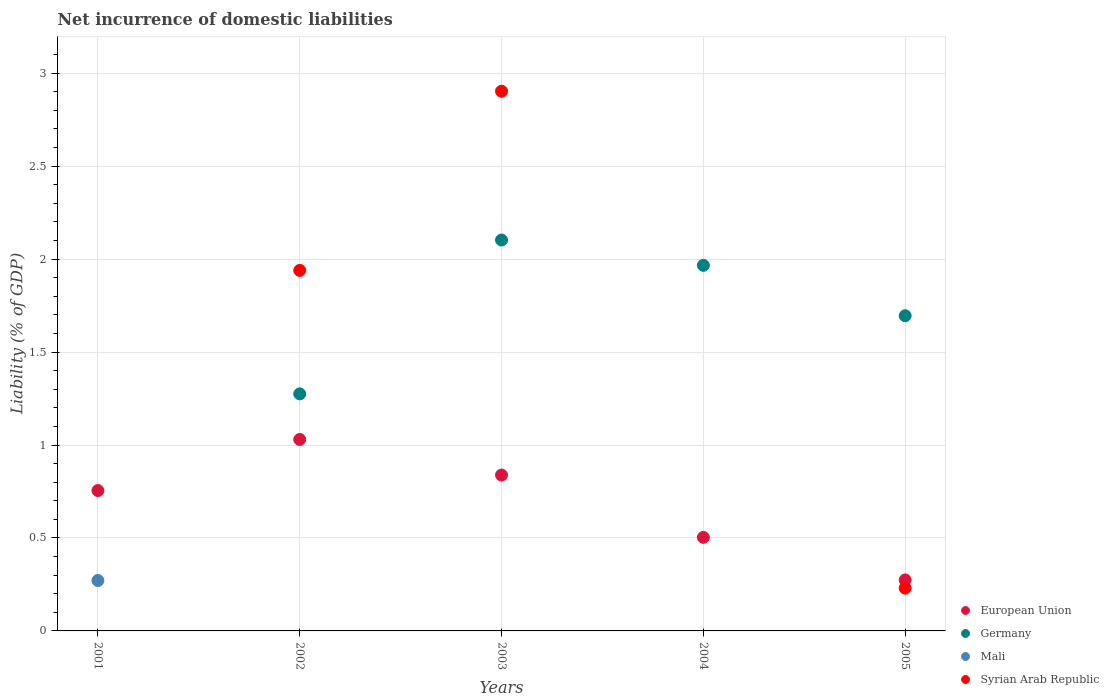How many different coloured dotlines are there?
Your response must be concise. 4. What is the net incurrence of domestic liabilities in European Union in 2003?
Offer a terse response. 0.84. Across all years, what is the maximum net incurrence of domestic liabilities in Mali?
Ensure brevity in your answer.  0.27. Across all years, what is the minimum net incurrence of domestic liabilities in Mali?
Your answer should be very brief. 0. In which year was the net incurrence of domestic liabilities in Syrian Arab Republic maximum?
Provide a succinct answer. 2003. What is the total net incurrence of domestic liabilities in European Union in the graph?
Offer a terse response. 3.4. What is the difference between the net incurrence of domestic liabilities in Syrian Arab Republic in 2002 and that in 2005?
Keep it short and to the point. 1.71. What is the difference between the net incurrence of domestic liabilities in European Union in 2004 and the net incurrence of domestic liabilities in Syrian Arab Republic in 2003?
Provide a short and direct response. -2.4. What is the average net incurrence of domestic liabilities in Mali per year?
Offer a terse response. 0.05. In the year 2004, what is the difference between the net incurrence of domestic liabilities in Germany and net incurrence of domestic liabilities in European Union?
Your answer should be compact. 1.46. What is the ratio of the net incurrence of domestic liabilities in European Union in 2002 to that in 2005?
Offer a terse response. 3.75. Is the net incurrence of domestic liabilities in Syrian Arab Republic in 2002 less than that in 2003?
Keep it short and to the point. Yes. Is the difference between the net incurrence of domestic liabilities in Germany in 2003 and 2005 greater than the difference between the net incurrence of domestic liabilities in European Union in 2003 and 2005?
Keep it short and to the point. No. What is the difference between the highest and the second highest net incurrence of domestic liabilities in European Union?
Your response must be concise. 0.19. What is the difference between the highest and the lowest net incurrence of domestic liabilities in Germany?
Keep it short and to the point. 2.1. In how many years, is the net incurrence of domestic liabilities in Mali greater than the average net incurrence of domestic liabilities in Mali taken over all years?
Your response must be concise. 1. Is it the case that in every year, the sum of the net incurrence of domestic liabilities in Germany and net incurrence of domestic liabilities in European Union  is greater than the sum of net incurrence of domestic liabilities in Mali and net incurrence of domestic liabilities in Syrian Arab Republic?
Your answer should be very brief. No. Is it the case that in every year, the sum of the net incurrence of domestic liabilities in Syrian Arab Republic and net incurrence of domestic liabilities in European Union  is greater than the net incurrence of domestic liabilities in Germany?
Give a very brief answer. No. Does the net incurrence of domestic liabilities in Mali monotonically increase over the years?
Your answer should be very brief. No. Is the net incurrence of domestic liabilities in Syrian Arab Republic strictly greater than the net incurrence of domestic liabilities in Mali over the years?
Offer a terse response. No. What is the difference between two consecutive major ticks on the Y-axis?
Provide a succinct answer. 0.5. Does the graph contain grids?
Offer a terse response. Yes. How are the legend labels stacked?
Make the answer very short. Vertical. What is the title of the graph?
Offer a very short reply. Net incurrence of domestic liabilities. Does "Belgium" appear as one of the legend labels in the graph?
Make the answer very short. No. What is the label or title of the X-axis?
Your answer should be very brief. Years. What is the label or title of the Y-axis?
Ensure brevity in your answer.  Liability (% of GDP). What is the Liability (% of GDP) of European Union in 2001?
Make the answer very short. 0.75. What is the Liability (% of GDP) of Germany in 2001?
Offer a terse response. 0. What is the Liability (% of GDP) in Mali in 2001?
Make the answer very short. 0.27. What is the Liability (% of GDP) of Syrian Arab Republic in 2001?
Offer a terse response. 0. What is the Liability (% of GDP) of European Union in 2002?
Offer a very short reply. 1.03. What is the Liability (% of GDP) in Germany in 2002?
Provide a succinct answer. 1.28. What is the Liability (% of GDP) of Mali in 2002?
Offer a terse response. 0. What is the Liability (% of GDP) of Syrian Arab Republic in 2002?
Your answer should be very brief. 1.94. What is the Liability (% of GDP) of European Union in 2003?
Make the answer very short. 0.84. What is the Liability (% of GDP) of Germany in 2003?
Keep it short and to the point. 2.1. What is the Liability (% of GDP) of Syrian Arab Republic in 2003?
Ensure brevity in your answer.  2.9. What is the Liability (% of GDP) in European Union in 2004?
Provide a succinct answer. 0.5. What is the Liability (% of GDP) in Germany in 2004?
Your response must be concise. 1.97. What is the Liability (% of GDP) of Mali in 2004?
Your answer should be very brief. 0. What is the Liability (% of GDP) in Syrian Arab Republic in 2004?
Make the answer very short. 0. What is the Liability (% of GDP) of European Union in 2005?
Your response must be concise. 0.27. What is the Liability (% of GDP) of Germany in 2005?
Your response must be concise. 1.7. What is the Liability (% of GDP) of Syrian Arab Republic in 2005?
Offer a very short reply. 0.23. Across all years, what is the maximum Liability (% of GDP) of European Union?
Make the answer very short. 1.03. Across all years, what is the maximum Liability (% of GDP) in Germany?
Give a very brief answer. 2.1. Across all years, what is the maximum Liability (% of GDP) of Mali?
Provide a succinct answer. 0.27. Across all years, what is the maximum Liability (% of GDP) in Syrian Arab Republic?
Give a very brief answer. 2.9. Across all years, what is the minimum Liability (% of GDP) in European Union?
Offer a very short reply. 0.27. Across all years, what is the minimum Liability (% of GDP) in Mali?
Ensure brevity in your answer.  0. Across all years, what is the minimum Liability (% of GDP) in Syrian Arab Republic?
Ensure brevity in your answer.  0. What is the total Liability (% of GDP) of European Union in the graph?
Provide a succinct answer. 3.4. What is the total Liability (% of GDP) in Germany in the graph?
Your response must be concise. 7.04. What is the total Liability (% of GDP) in Mali in the graph?
Ensure brevity in your answer.  0.27. What is the total Liability (% of GDP) in Syrian Arab Republic in the graph?
Provide a short and direct response. 5.07. What is the difference between the Liability (% of GDP) of European Union in 2001 and that in 2002?
Your answer should be very brief. -0.27. What is the difference between the Liability (% of GDP) in European Union in 2001 and that in 2003?
Your answer should be very brief. -0.08. What is the difference between the Liability (% of GDP) of European Union in 2001 and that in 2004?
Your answer should be very brief. 0.25. What is the difference between the Liability (% of GDP) of European Union in 2001 and that in 2005?
Give a very brief answer. 0.48. What is the difference between the Liability (% of GDP) of European Union in 2002 and that in 2003?
Provide a succinct answer. 0.19. What is the difference between the Liability (% of GDP) in Germany in 2002 and that in 2003?
Offer a very short reply. -0.83. What is the difference between the Liability (% of GDP) of Syrian Arab Republic in 2002 and that in 2003?
Make the answer very short. -0.96. What is the difference between the Liability (% of GDP) in European Union in 2002 and that in 2004?
Your answer should be compact. 0.53. What is the difference between the Liability (% of GDP) of Germany in 2002 and that in 2004?
Give a very brief answer. -0.69. What is the difference between the Liability (% of GDP) of European Union in 2002 and that in 2005?
Ensure brevity in your answer.  0.76. What is the difference between the Liability (% of GDP) in Germany in 2002 and that in 2005?
Give a very brief answer. -0.42. What is the difference between the Liability (% of GDP) of Syrian Arab Republic in 2002 and that in 2005?
Give a very brief answer. 1.71. What is the difference between the Liability (% of GDP) of European Union in 2003 and that in 2004?
Keep it short and to the point. 0.34. What is the difference between the Liability (% of GDP) in Germany in 2003 and that in 2004?
Provide a succinct answer. 0.14. What is the difference between the Liability (% of GDP) in European Union in 2003 and that in 2005?
Provide a succinct answer. 0.56. What is the difference between the Liability (% of GDP) of Germany in 2003 and that in 2005?
Provide a short and direct response. 0.41. What is the difference between the Liability (% of GDP) in Syrian Arab Republic in 2003 and that in 2005?
Make the answer very short. 2.67. What is the difference between the Liability (% of GDP) in European Union in 2004 and that in 2005?
Your answer should be compact. 0.23. What is the difference between the Liability (% of GDP) of Germany in 2004 and that in 2005?
Keep it short and to the point. 0.27. What is the difference between the Liability (% of GDP) of European Union in 2001 and the Liability (% of GDP) of Germany in 2002?
Ensure brevity in your answer.  -0.52. What is the difference between the Liability (% of GDP) of European Union in 2001 and the Liability (% of GDP) of Syrian Arab Republic in 2002?
Ensure brevity in your answer.  -1.18. What is the difference between the Liability (% of GDP) of Mali in 2001 and the Liability (% of GDP) of Syrian Arab Republic in 2002?
Offer a terse response. -1.67. What is the difference between the Liability (% of GDP) of European Union in 2001 and the Liability (% of GDP) of Germany in 2003?
Your answer should be very brief. -1.35. What is the difference between the Liability (% of GDP) in European Union in 2001 and the Liability (% of GDP) in Syrian Arab Republic in 2003?
Offer a terse response. -2.15. What is the difference between the Liability (% of GDP) of Mali in 2001 and the Liability (% of GDP) of Syrian Arab Republic in 2003?
Ensure brevity in your answer.  -2.63. What is the difference between the Liability (% of GDP) of European Union in 2001 and the Liability (% of GDP) of Germany in 2004?
Ensure brevity in your answer.  -1.21. What is the difference between the Liability (% of GDP) in European Union in 2001 and the Liability (% of GDP) in Germany in 2005?
Offer a terse response. -0.94. What is the difference between the Liability (% of GDP) of European Union in 2001 and the Liability (% of GDP) of Syrian Arab Republic in 2005?
Offer a terse response. 0.53. What is the difference between the Liability (% of GDP) of Mali in 2001 and the Liability (% of GDP) of Syrian Arab Republic in 2005?
Your response must be concise. 0.04. What is the difference between the Liability (% of GDP) of European Union in 2002 and the Liability (% of GDP) of Germany in 2003?
Your response must be concise. -1.07. What is the difference between the Liability (% of GDP) of European Union in 2002 and the Liability (% of GDP) of Syrian Arab Republic in 2003?
Give a very brief answer. -1.87. What is the difference between the Liability (% of GDP) in Germany in 2002 and the Liability (% of GDP) in Syrian Arab Republic in 2003?
Ensure brevity in your answer.  -1.63. What is the difference between the Liability (% of GDP) in European Union in 2002 and the Liability (% of GDP) in Germany in 2004?
Make the answer very short. -0.94. What is the difference between the Liability (% of GDP) in European Union in 2002 and the Liability (% of GDP) in Germany in 2005?
Make the answer very short. -0.67. What is the difference between the Liability (% of GDP) in European Union in 2002 and the Liability (% of GDP) in Syrian Arab Republic in 2005?
Your answer should be very brief. 0.8. What is the difference between the Liability (% of GDP) in Germany in 2002 and the Liability (% of GDP) in Syrian Arab Republic in 2005?
Your answer should be very brief. 1.05. What is the difference between the Liability (% of GDP) in European Union in 2003 and the Liability (% of GDP) in Germany in 2004?
Ensure brevity in your answer.  -1.13. What is the difference between the Liability (% of GDP) of European Union in 2003 and the Liability (% of GDP) of Germany in 2005?
Your answer should be compact. -0.86. What is the difference between the Liability (% of GDP) in European Union in 2003 and the Liability (% of GDP) in Syrian Arab Republic in 2005?
Your answer should be compact. 0.61. What is the difference between the Liability (% of GDP) of Germany in 2003 and the Liability (% of GDP) of Syrian Arab Republic in 2005?
Offer a terse response. 1.87. What is the difference between the Liability (% of GDP) of European Union in 2004 and the Liability (% of GDP) of Germany in 2005?
Offer a very short reply. -1.19. What is the difference between the Liability (% of GDP) in European Union in 2004 and the Liability (% of GDP) in Syrian Arab Republic in 2005?
Ensure brevity in your answer.  0.27. What is the difference between the Liability (% of GDP) in Germany in 2004 and the Liability (% of GDP) in Syrian Arab Republic in 2005?
Ensure brevity in your answer.  1.74. What is the average Liability (% of GDP) in European Union per year?
Offer a terse response. 0.68. What is the average Liability (% of GDP) of Germany per year?
Offer a terse response. 1.41. What is the average Liability (% of GDP) of Mali per year?
Ensure brevity in your answer.  0.05. What is the average Liability (% of GDP) in Syrian Arab Republic per year?
Provide a short and direct response. 1.01. In the year 2001, what is the difference between the Liability (% of GDP) of European Union and Liability (% of GDP) of Mali?
Your response must be concise. 0.48. In the year 2002, what is the difference between the Liability (% of GDP) of European Union and Liability (% of GDP) of Germany?
Your answer should be very brief. -0.25. In the year 2002, what is the difference between the Liability (% of GDP) in European Union and Liability (% of GDP) in Syrian Arab Republic?
Make the answer very short. -0.91. In the year 2002, what is the difference between the Liability (% of GDP) of Germany and Liability (% of GDP) of Syrian Arab Republic?
Give a very brief answer. -0.66. In the year 2003, what is the difference between the Liability (% of GDP) of European Union and Liability (% of GDP) of Germany?
Offer a terse response. -1.26. In the year 2003, what is the difference between the Liability (% of GDP) of European Union and Liability (% of GDP) of Syrian Arab Republic?
Your answer should be compact. -2.06. In the year 2003, what is the difference between the Liability (% of GDP) of Germany and Liability (% of GDP) of Syrian Arab Republic?
Provide a short and direct response. -0.8. In the year 2004, what is the difference between the Liability (% of GDP) of European Union and Liability (% of GDP) of Germany?
Your answer should be compact. -1.46. In the year 2005, what is the difference between the Liability (% of GDP) of European Union and Liability (% of GDP) of Germany?
Ensure brevity in your answer.  -1.42. In the year 2005, what is the difference between the Liability (% of GDP) in European Union and Liability (% of GDP) in Syrian Arab Republic?
Provide a short and direct response. 0.04. In the year 2005, what is the difference between the Liability (% of GDP) in Germany and Liability (% of GDP) in Syrian Arab Republic?
Provide a succinct answer. 1.47. What is the ratio of the Liability (% of GDP) of European Union in 2001 to that in 2002?
Offer a terse response. 0.73. What is the ratio of the Liability (% of GDP) in European Union in 2001 to that in 2003?
Provide a short and direct response. 0.9. What is the ratio of the Liability (% of GDP) in European Union in 2001 to that in 2004?
Your answer should be compact. 1.5. What is the ratio of the Liability (% of GDP) of European Union in 2001 to that in 2005?
Keep it short and to the point. 2.75. What is the ratio of the Liability (% of GDP) of European Union in 2002 to that in 2003?
Ensure brevity in your answer.  1.23. What is the ratio of the Liability (% of GDP) in Germany in 2002 to that in 2003?
Offer a terse response. 0.61. What is the ratio of the Liability (% of GDP) in Syrian Arab Republic in 2002 to that in 2003?
Provide a short and direct response. 0.67. What is the ratio of the Liability (% of GDP) of European Union in 2002 to that in 2004?
Your answer should be compact. 2.05. What is the ratio of the Liability (% of GDP) in Germany in 2002 to that in 2004?
Provide a succinct answer. 0.65. What is the ratio of the Liability (% of GDP) in European Union in 2002 to that in 2005?
Offer a terse response. 3.75. What is the ratio of the Liability (% of GDP) in Germany in 2002 to that in 2005?
Provide a succinct answer. 0.75. What is the ratio of the Liability (% of GDP) in Syrian Arab Republic in 2002 to that in 2005?
Offer a very short reply. 8.43. What is the ratio of the Liability (% of GDP) of European Union in 2003 to that in 2004?
Your answer should be very brief. 1.67. What is the ratio of the Liability (% of GDP) of Germany in 2003 to that in 2004?
Offer a very short reply. 1.07. What is the ratio of the Liability (% of GDP) of European Union in 2003 to that in 2005?
Your response must be concise. 3.06. What is the ratio of the Liability (% of GDP) of Germany in 2003 to that in 2005?
Provide a short and direct response. 1.24. What is the ratio of the Liability (% of GDP) of Syrian Arab Republic in 2003 to that in 2005?
Your response must be concise. 12.62. What is the ratio of the Liability (% of GDP) of European Union in 2004 to that in 2005?
Provide a succinct answer. 1.83. What is the ratio of the Liability (% of GDP) in Germany in 2004 to that in 2005?
Offer a very short reply. 1.16. What is the difference between the highest and the second highest Liability (% of GDP) in European Union?
Make the answer very short. 0.19. What is the difference between the highest and the second highest Liability (% of GDP) of Germany?
Give a very brief answer. 0.14. What is the difference between the highest and the second highest Liability (% of GDP) of Syrian Arab Republic?
Keep it short and to the point. 0.96. What is the difference between the highest and the lowest Liability (% of GDP) of European Union?
Keep it short and to the point. 0.76. What is the difference between the highest and the lowest Liability (% of GDP) of Germany?
Keep it short and to the point. 2.1. What is the difference between the highest and the lowest Liability (% of GDP) in Mali?
Provide a succinct answer. 0.27. What is the difference between the highest and the lowest Liability (% of GDP) of Syrian Arab Republic?
Your response must be concise. 2.9. 